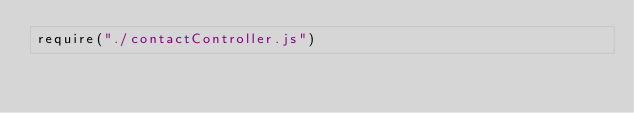<code> <loc_0><loc_0><loc_500><loc_500><_JavaScript_>require("./contactController.js")</code> 